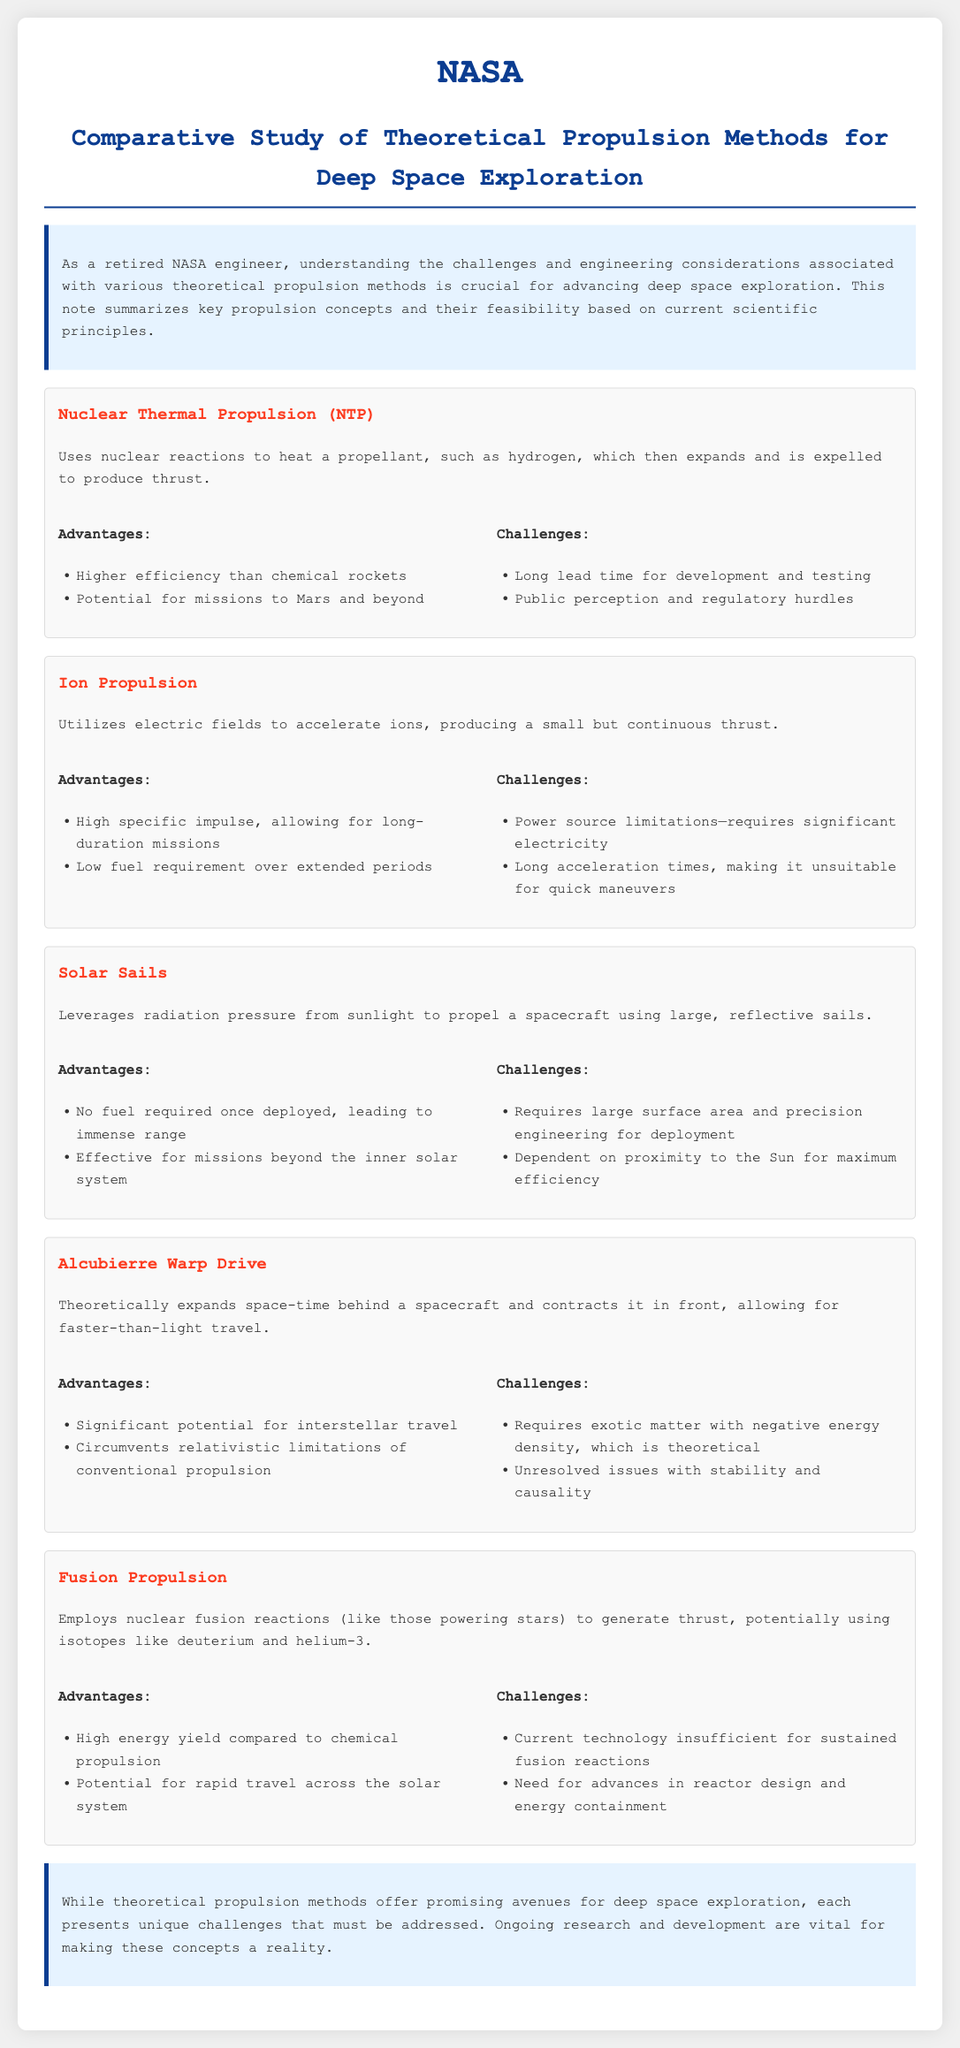What propulsion method utilizes nuclear reactions? The propulsion method that utilizes nuclear reactions is Nuclear Thermal Propulsion.
Answer: Nuclear Thermal Propulsion What is the specific impulse advantage of Ion Propulsion? Ion Propulsion has a high specific impulse, allowing for long-duration missions.
Answer: High specific impulse What is one challenge associated with Solar Sails? One challenge associated with Solar Sails is that it requires a large surface area and precision engineering for deployment.
Answer: Large surface area What exotic mater is required for the Alcubierre Warp Drive? The Alcubierre Warp Drive requires exotic matter with negative energy density.
Answer: Exotic matter with negative energy density How many advantages are listed for Fusion Propulsion? There are two advantages listed for Fusion Propulsion.
Answer: Two What propulsion method is noted for its potential for interstellar travel? The propulsion method noted for its potential for interstellar travel is the Alcubierre Warp Drive.
Answer: Alcubierre Warp Drive What is the primary challenge for Nuclear Thermal Propulsion? The primary challenge for Nuclear Thermal Propulsion is the long lead time for development and testing.
Answer: Long lead time Which propulsion method leverages radiation pressure? The propulsion method that leverages radiation pressure is Solar Sails.
Answer: Solar Sails 